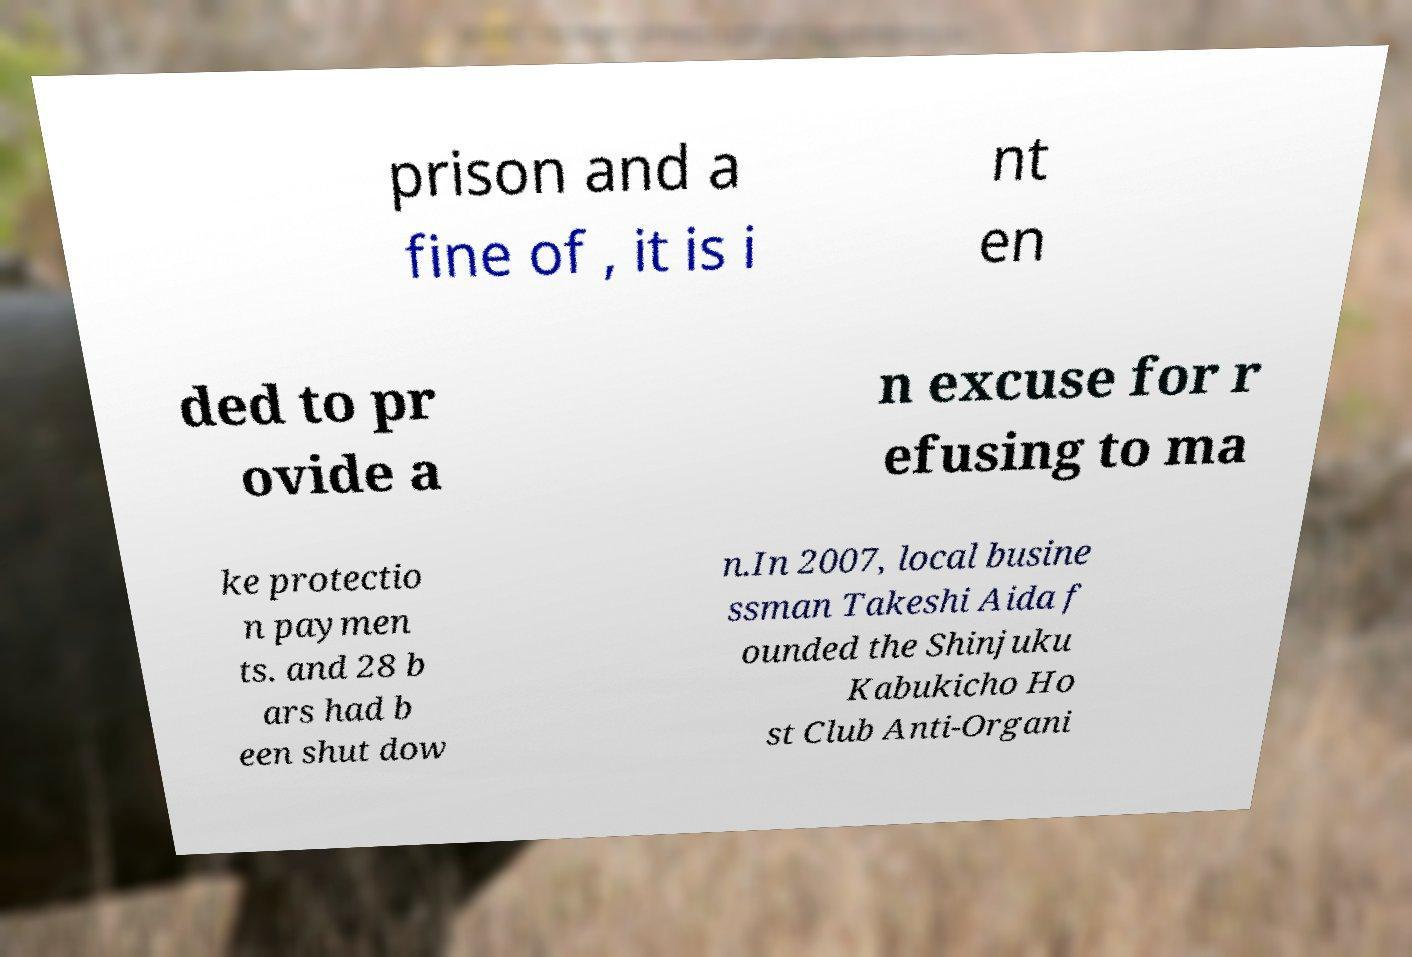For documentation purposes, I need the text within this image transcribed. Could you provide that? prison and a fine of , it is i nt en ded to pr ovide a n excuse for r efusing to ma ke protectio n paymen ts. and 28 b ars had b een shut dow n.In 2007, local busine ssman Takeshi Aida f ounded the Shinjuku Kabukicho Ho st Club Anti-Organi 